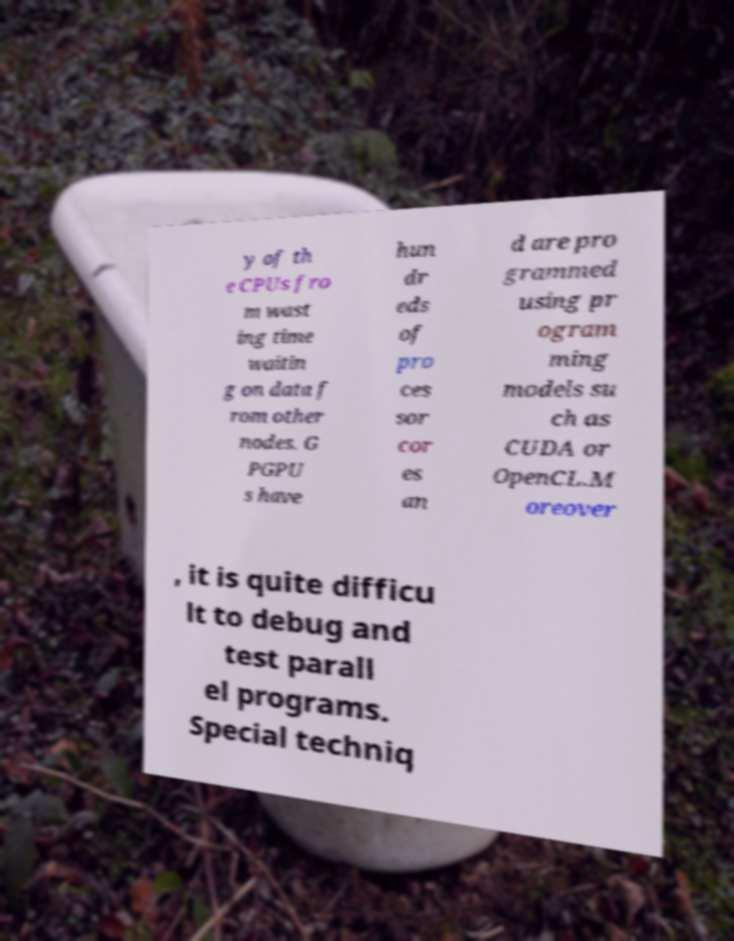For documentation purposes, I need the text within this image transcribed. Could you provide that? y of th e CPUs fro m wast ing time waitin g on data f rom other nodes. G PGPU s have hun dr eds of pro ces sor cor es an d are pro grammed using pr ogram ming models su ch as CUDA or OpenCL.M oreover , it is quite difficu lt to debug and test parall el programs. Special techniq 